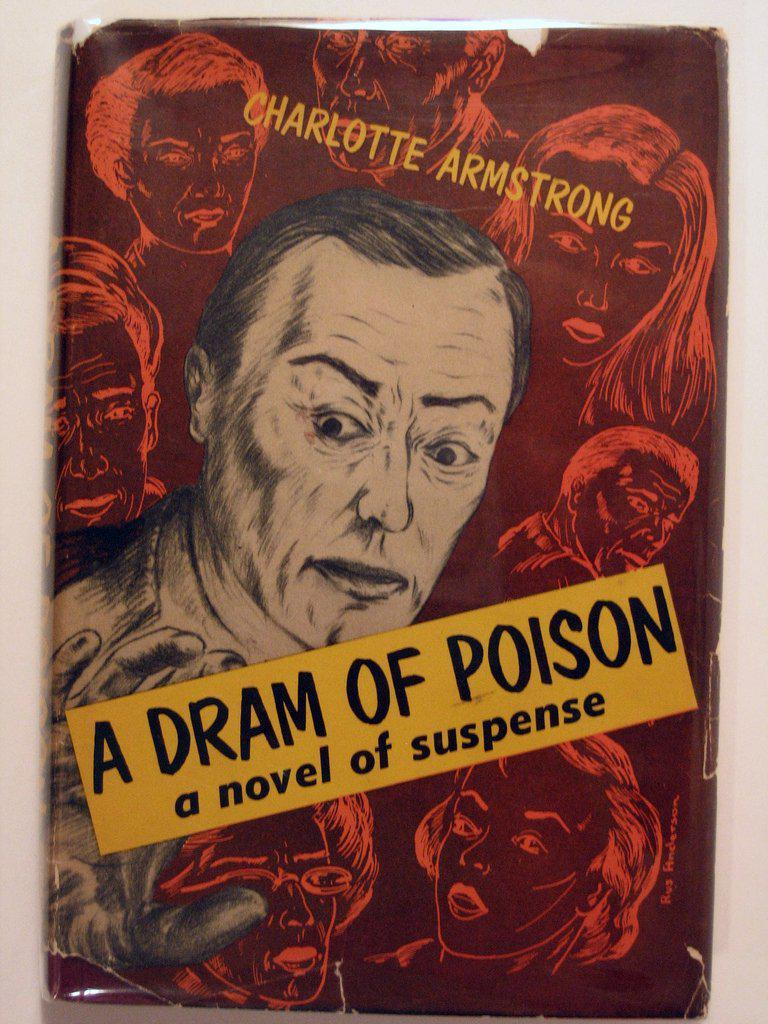What is the main subject of the image? The main subject of the image is a book cover. What can be seen on the book cover? There are faces visible on the book cover. What else is present on the book cover besides the faces? There is text on the book cover. What type of mist can be seen surrounding the book cover in the image? There is no mist present in the image; it only features a book cover with faces and text. 